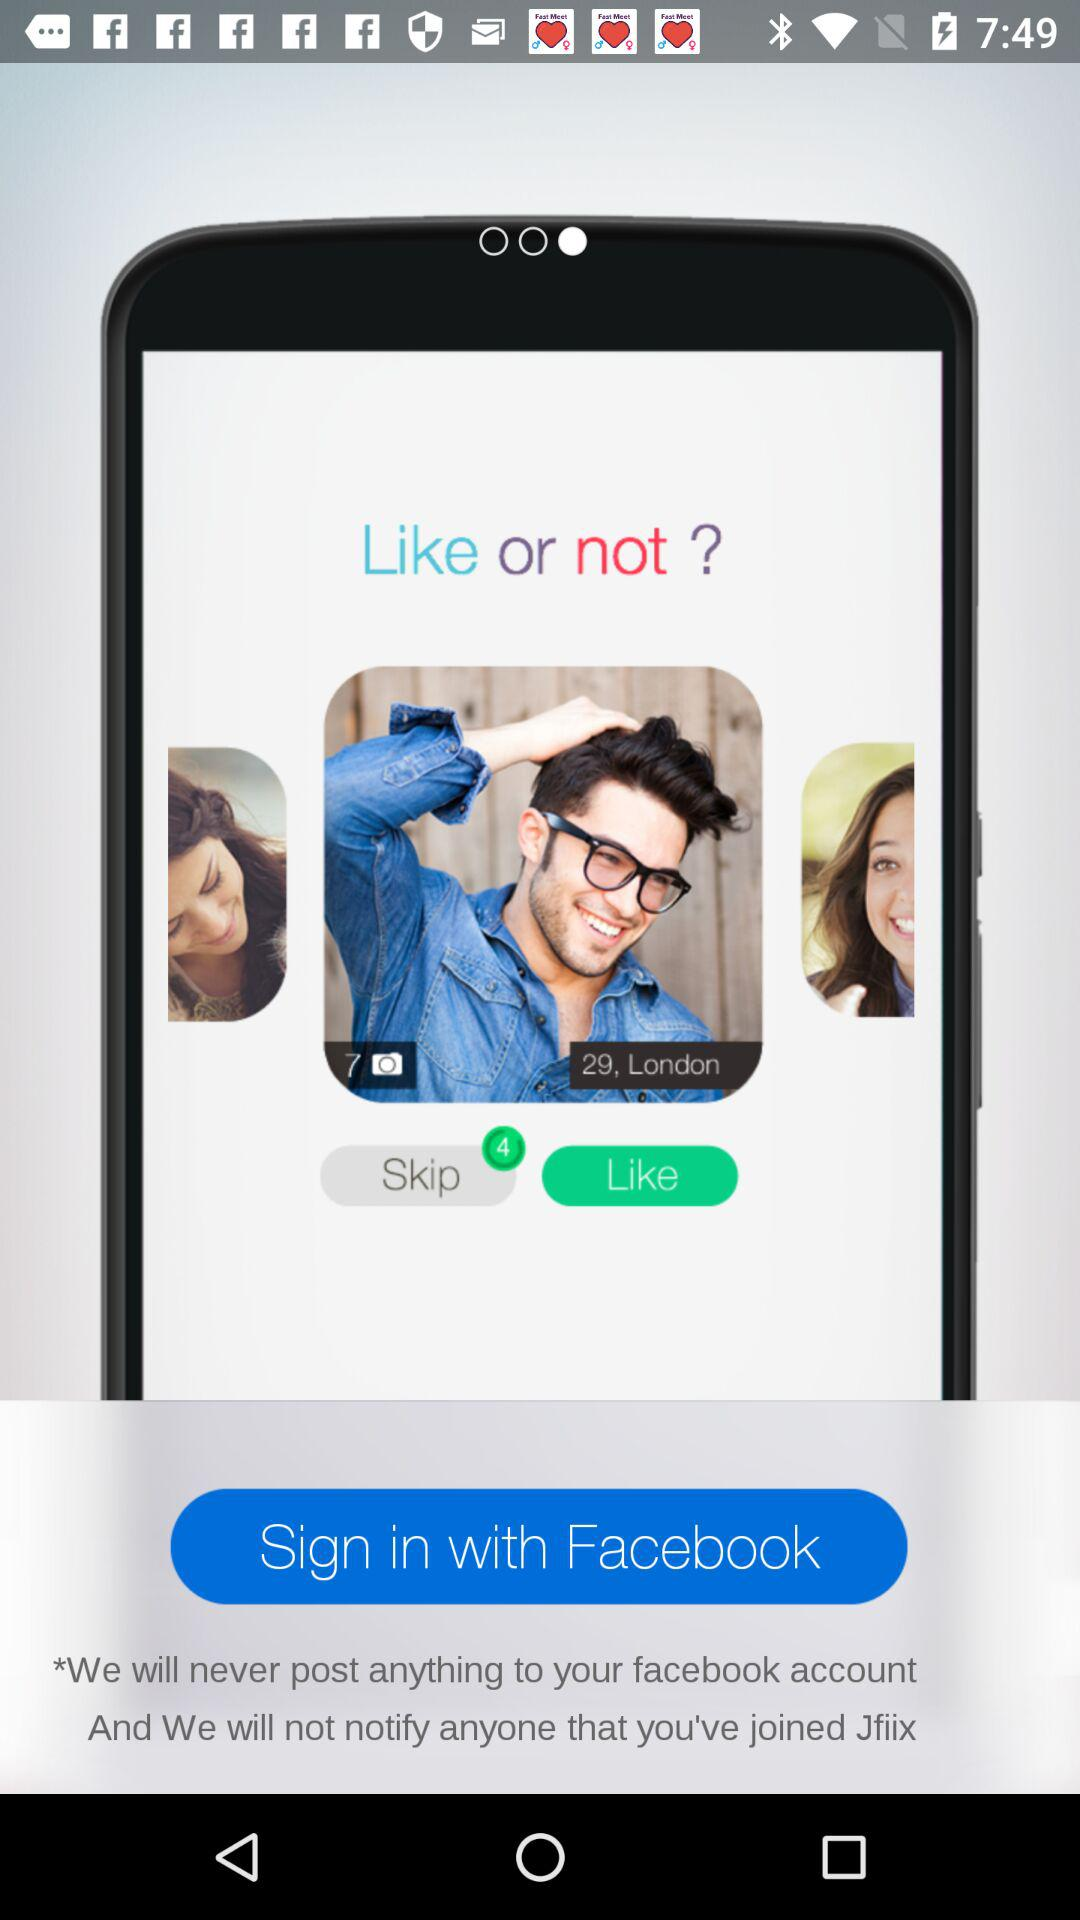How many women are shown on this screen?
Answer the question using a single word or phrase. 2 